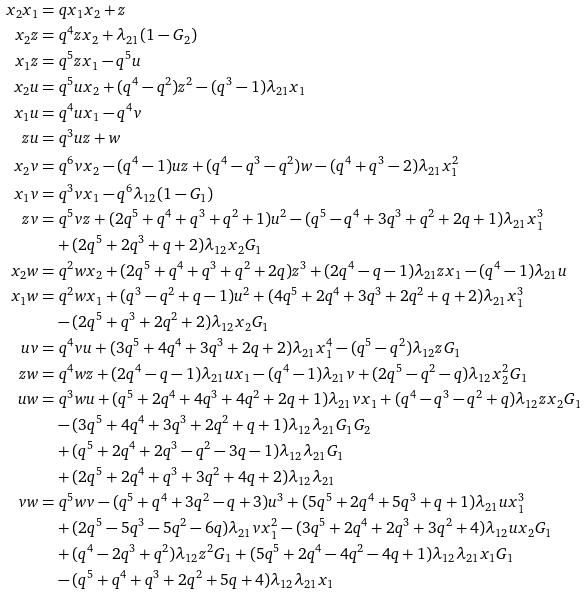<formula> <loc_0><loc_0><loc_500><loc_500>x _ { 2 } x _ { 1 } & = q x _ { 1 } x _ { 2 } + z \\ x _ { 2 } z & = q ^ { 4 } z x _ { 2 } + \lambda _ { 2 1 } ( 1 - G _ { 2 } ) \\ x _ { 1 } z & = q ^ { 5 } z x _ { 1 } - q ^ { 5 } u \\ x _ { 2 } u & = q ^ { 5 } u x _ { 2 } + ( q ^ { 4 } - q ^ { 2 } ) z ^ { 2 } - ( q ^ { 3 } - 1 ) \lambda _ { 2 1 } x _ { 1 } \\ x _ { 1 } u & = q ^ { 4 } u x _ { 1 } - q ^ { 4 } v \\ z u & = q ^ { 3 } u z + w \\ x _ { 2 } v & = q ^ { 6 } v x _ { 2 } - ( q ^ { 4 } - 1 ) u z + ( q ^ { 4 } - q ^ { 3 } - q ^ { 2 } ) w - ( q ^ { 4 } + q ^ { 3 } - 2 ) \lambda _ { 2 1 } x _ { 1 } ^ { 2 } \\ x _ { 1 } v & = q ^ { 3 } v x _ { 1 } - q ^ { 6 } \lambda _ { 1 2 } ( 1 - G _ { 1 } ) \\ z v & = q ^ { 5 } v z + ( 2 q ^ { 5 } + q ^ { 4 } + q ^ { 3 } + q ^ { 2 } + 1 ) u ^ { 2 } - ( q ^ { 5 } - q ^ { 4 } + 3 q ^ { 3 } + q ^ { 2 } + 2 q + 1 ) \lambda _ { 2 1 } x _ { 1 } ^ { 3 } \\ & \quad + ( 2 q ^ { 5 } + 2 q ^ { 3 } + q + 2 ) \lambda _ { 1 2 } x _ { 2 } G _ { 1 } \\ x _ { 2 } w & = q ^ { 2 } w x _ { 2 } + ( 2 q ^ { 5 } + q ^ { 4 } + q ^ { 3 } + q ^ { 2 } + 2 q ) z ^ { 3 } + ( 2 q ^ { 4 } - q - 1 ) \lambda _ { 2 1 } z x _ { 1 } - ( q ^ { 4 } - 1 ) \lambda _ { 2 1 } u \\ x _ { 1 } w & = q ^ { 2 } w x _ { 1 } + ( q ^ { 3 } - q ^ { 2 } + q - 1 ) u ^ { 2 } + ( 4 q ^ { 5 } + 2 q ^ { 4 } + 3 q ^ { 3 } + 2 q ^ { 2 } + q + 2 ) \lambda _ { 2 1 } x _ { 1 } ^ { 3 } \\ & \quad - ( 2 q ^ { 5 } + q ^ { 3 } + 2 q ^ { 2 } + 2 ) \lambda _ { 1 2 } x _ { 2 } G _ { 1 } \\ u v & = q ^ { 4 } v u + ( 3 q ^ { 5 } + 4 q ^ { 4 } + 3 q ^ { 3 } + 2 q + 2 ) \lambda _ { 2 1 } x _ { 1 } ^ { 4 } - ( q ^ { 5 } - q ^ { 2 } ) \lambda _ { 1 2 } z G _ { 1 } \\ z w & = q ^ { 4 } w z + ( 2 q ^ { 4 } - q - 1 ) \lambda _ { 2 1 } u x _ { 1 } - ( q ^ { 4 } - 1 ) \lambda _ { 2 1 } v + ( 2 q ^ { 5 } - q ^ { 2 } - q ) \lambda _ { 1 2 } x _ { 2 } ^ { 2 } G _ { 1 } \\ u w & = q ^ { 3 } w u + ( q ^ { 5 } + 2 q ^ { 4 } + 4 q ^ { 3 } + 4 q ^ { 2 } + 2 q + 1 ) \lambda _ { 2 1 } v x _ { 1 } + ( q ^ { 4 } - q ^ { 3 } - q ^ { 2 } + q ) \lambda _ { 1 2 } z x _ { 2 } G _ { 1 } \\ & \quad - ( 3 q ^ { 5 } + 4 q ^ { 4 } + 3 q ^ { 3 } + 2 q ^ { 2 } + q + 1 ) \lambda _ { 1 2 } \lambda _ { 2 1 } G _ { 1 } G _ { 2 } \\ & \quad + ( q ^ { 5 } + 2 q ^ { 4 } + 2 q ^ { 3 } - q ^ { 2 } - 3 q - 1 ) \lambda _ { 1 2 } \lambda _ { 2 1 } G _ { 1 } \\ & \quad + ( 2 q ^ { 5 } + 2 q ^ { 4 } + q ^ { 3 } + 3 q ^ { 2 } + 4 q + 2 ) \lambda _ { 1 2 } \lambda _ { 2 1 } \\ v w & = q ^ { 5 } w v - ( q ^ { 5 } + q ^ { 4 } + 3 q ^ { 2 } - q + 3 ) u ^ { 3 } + ( 5 q ^ { 5 } + 2 q ^ { 4 } + 5 q ^ { 3 } + q + 1 ) \lambda _ { 2 1 } u x _ { 1 } ^ { 3 } \\ & \quad + ( 2 q ^ { 5 } - 5 q ^ { 3 } - 5 q ^ { 2 } - 6 q ) \lambda _ { 2 1 } v x _ { 1 } ^ { 2 } - ( 3 q ^ { 5 } + 2 q ^ { 4 } + 2 q ^ { 3 } + 3 q ^ { 2 } + 4 ) \lambda _ { 1 2 } u x _ { 2 } G _ { 1 } \\ & \quad + ( q ^ { 4 } - 2 q ^ { 3 } + q ^ { 2 } ) \lambda _ { 1 2 } z ^ { 2 } G _ { 1 } + ( 5 q ^ { 5 } + 2 q ^ { 4 } - 4 q ^ { 2 } - 4 q + 1 ) \lambda _ { 1 2 } \lambda _ { 2 1 } x _ { 1 } G _ { 1 } \\ & \quad - ( q ^ { 5 } + q ^ { 4 } + q ^ { 3 } + 2 q ^ { 2 } + 5 q + 4 ) \lambda _ { 1 2 } \lambda _ { 2 1 } x _ { 1 }</formula> 